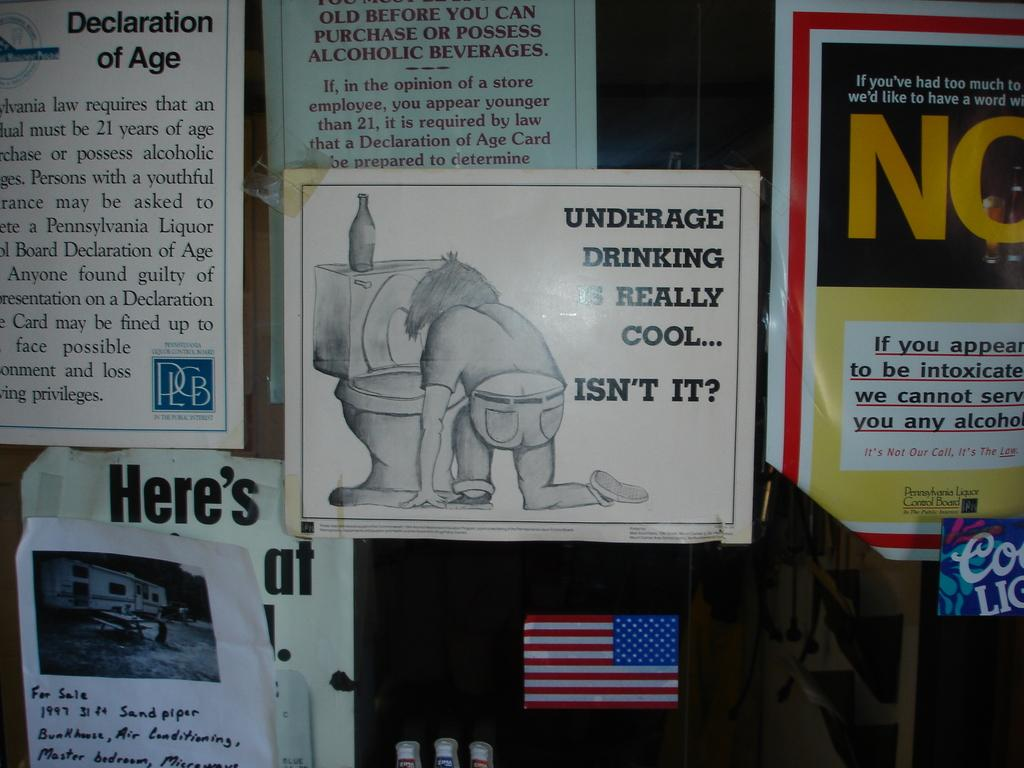<image>
Create a compact narrative representing the image presented. Various posters and fliers are on a wall, including one asking if underage drinking is really cool. 